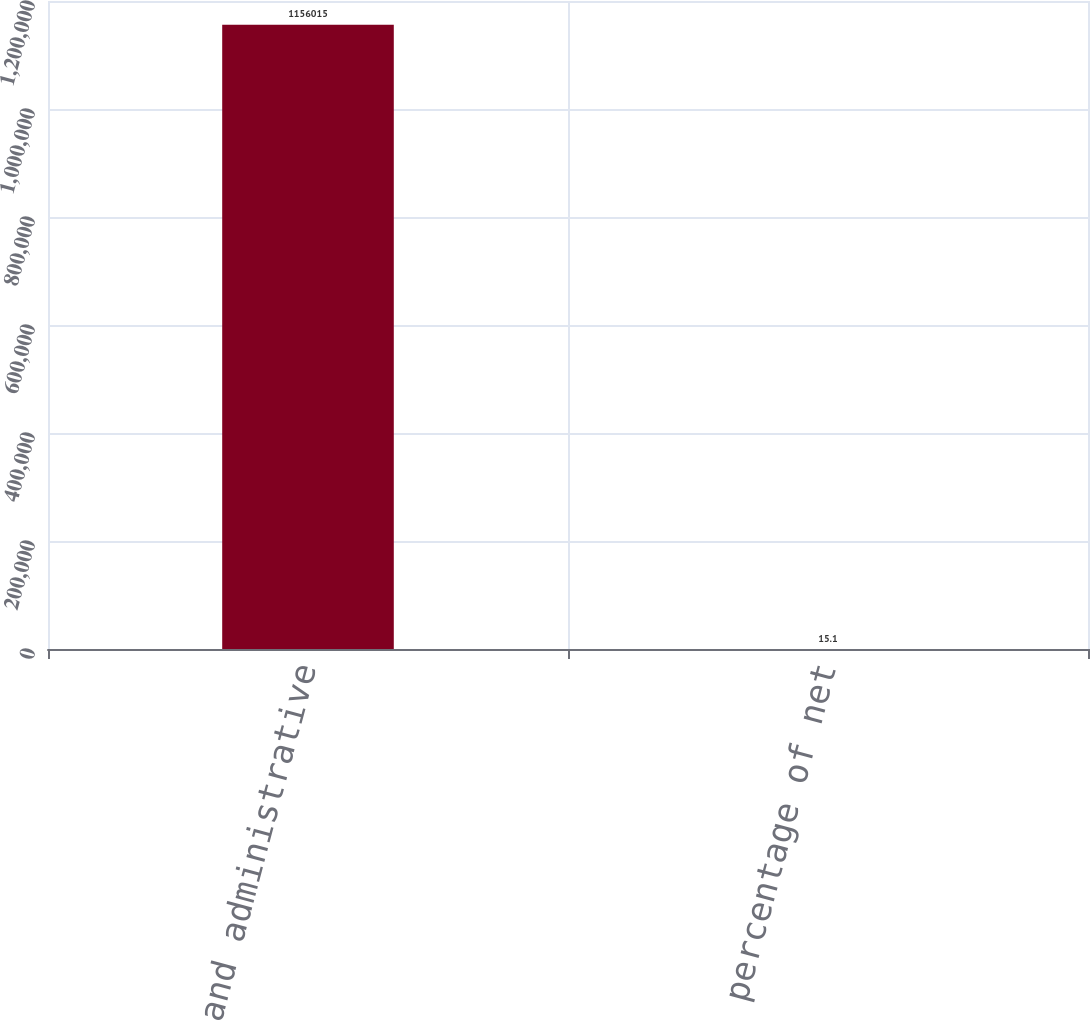<chart> <loc_0><loc_0><loc_500><loc_500><bar_chart><fcel>General and administrative<fcel>As a percentage of net<nl><fcel>1.15602e+06<fcel>15.1<nl></chart> 